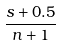Convert formula to latex. <formula><loc_0><loc_0><loc_500><loc_500>\frac { s + 0 . 5 } { n + 1 }</formula> 